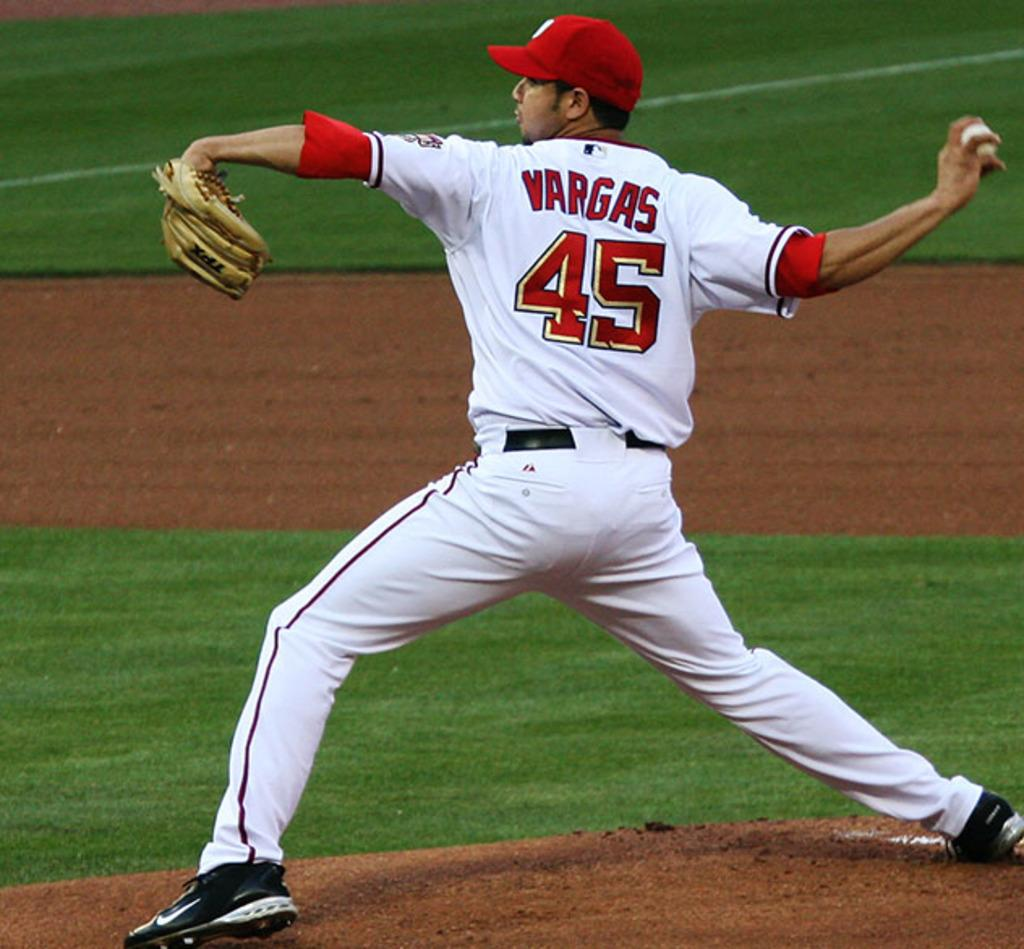<image>
Render a clear and concise summary of the photo. a man that has the name Vargas on his jersey 